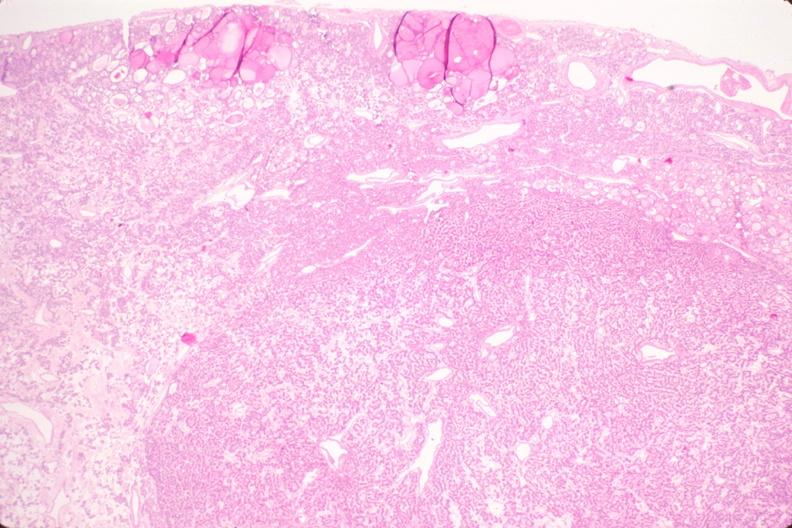what does this image show?
Answer the question using a single word or phrase. Thyroid 